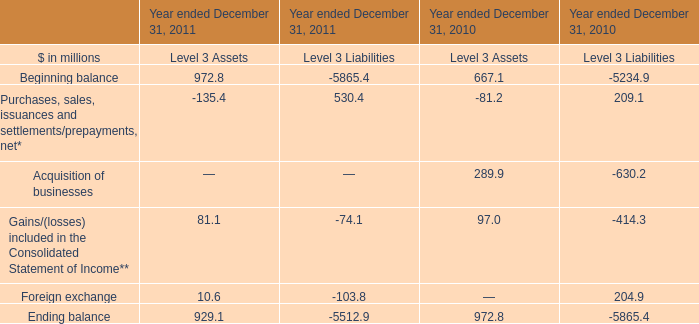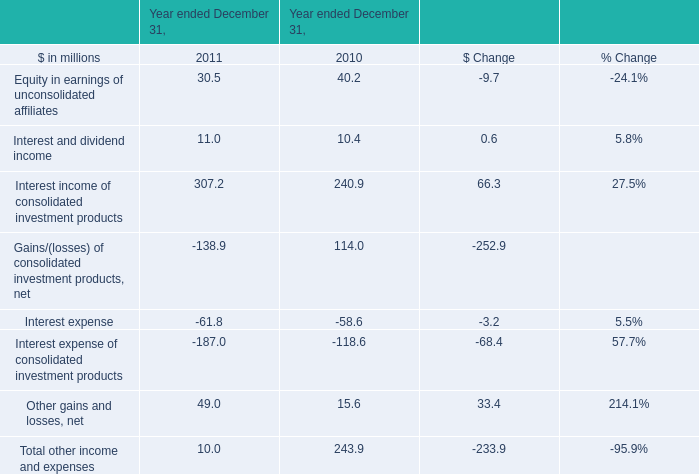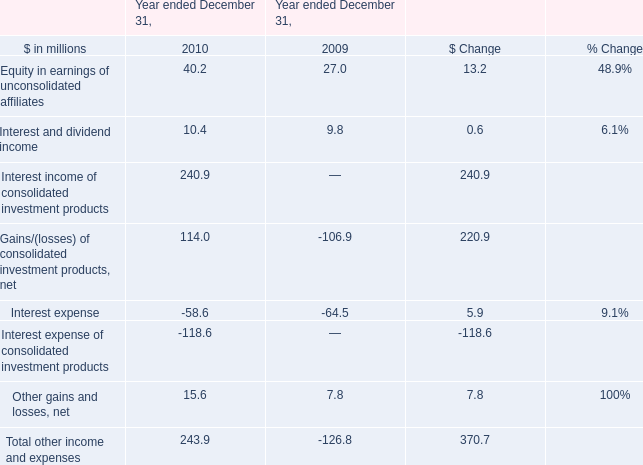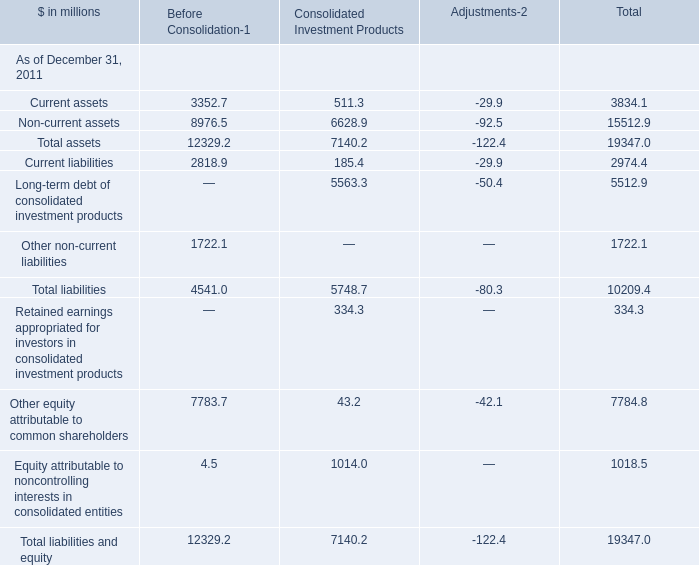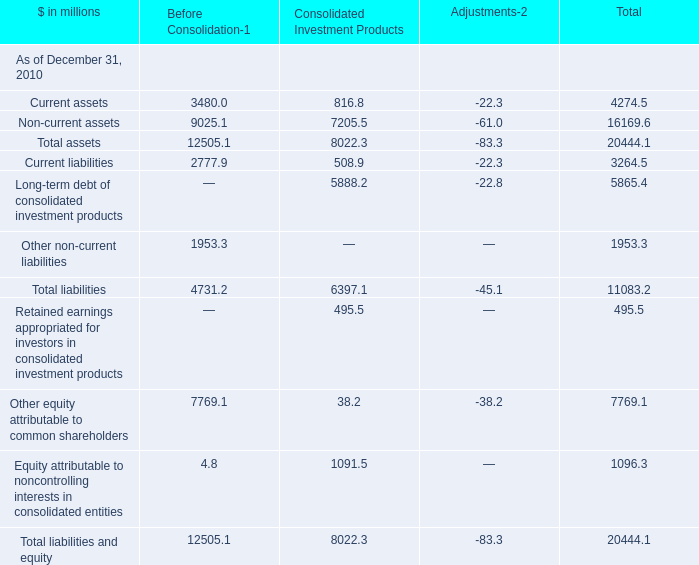In the section with lowest amount of Current assets, what's the increasing rate of Current liabilities ? 
Computations: ((2818.9 - 185.4) / 185.4)
Answer: 14.20442. 